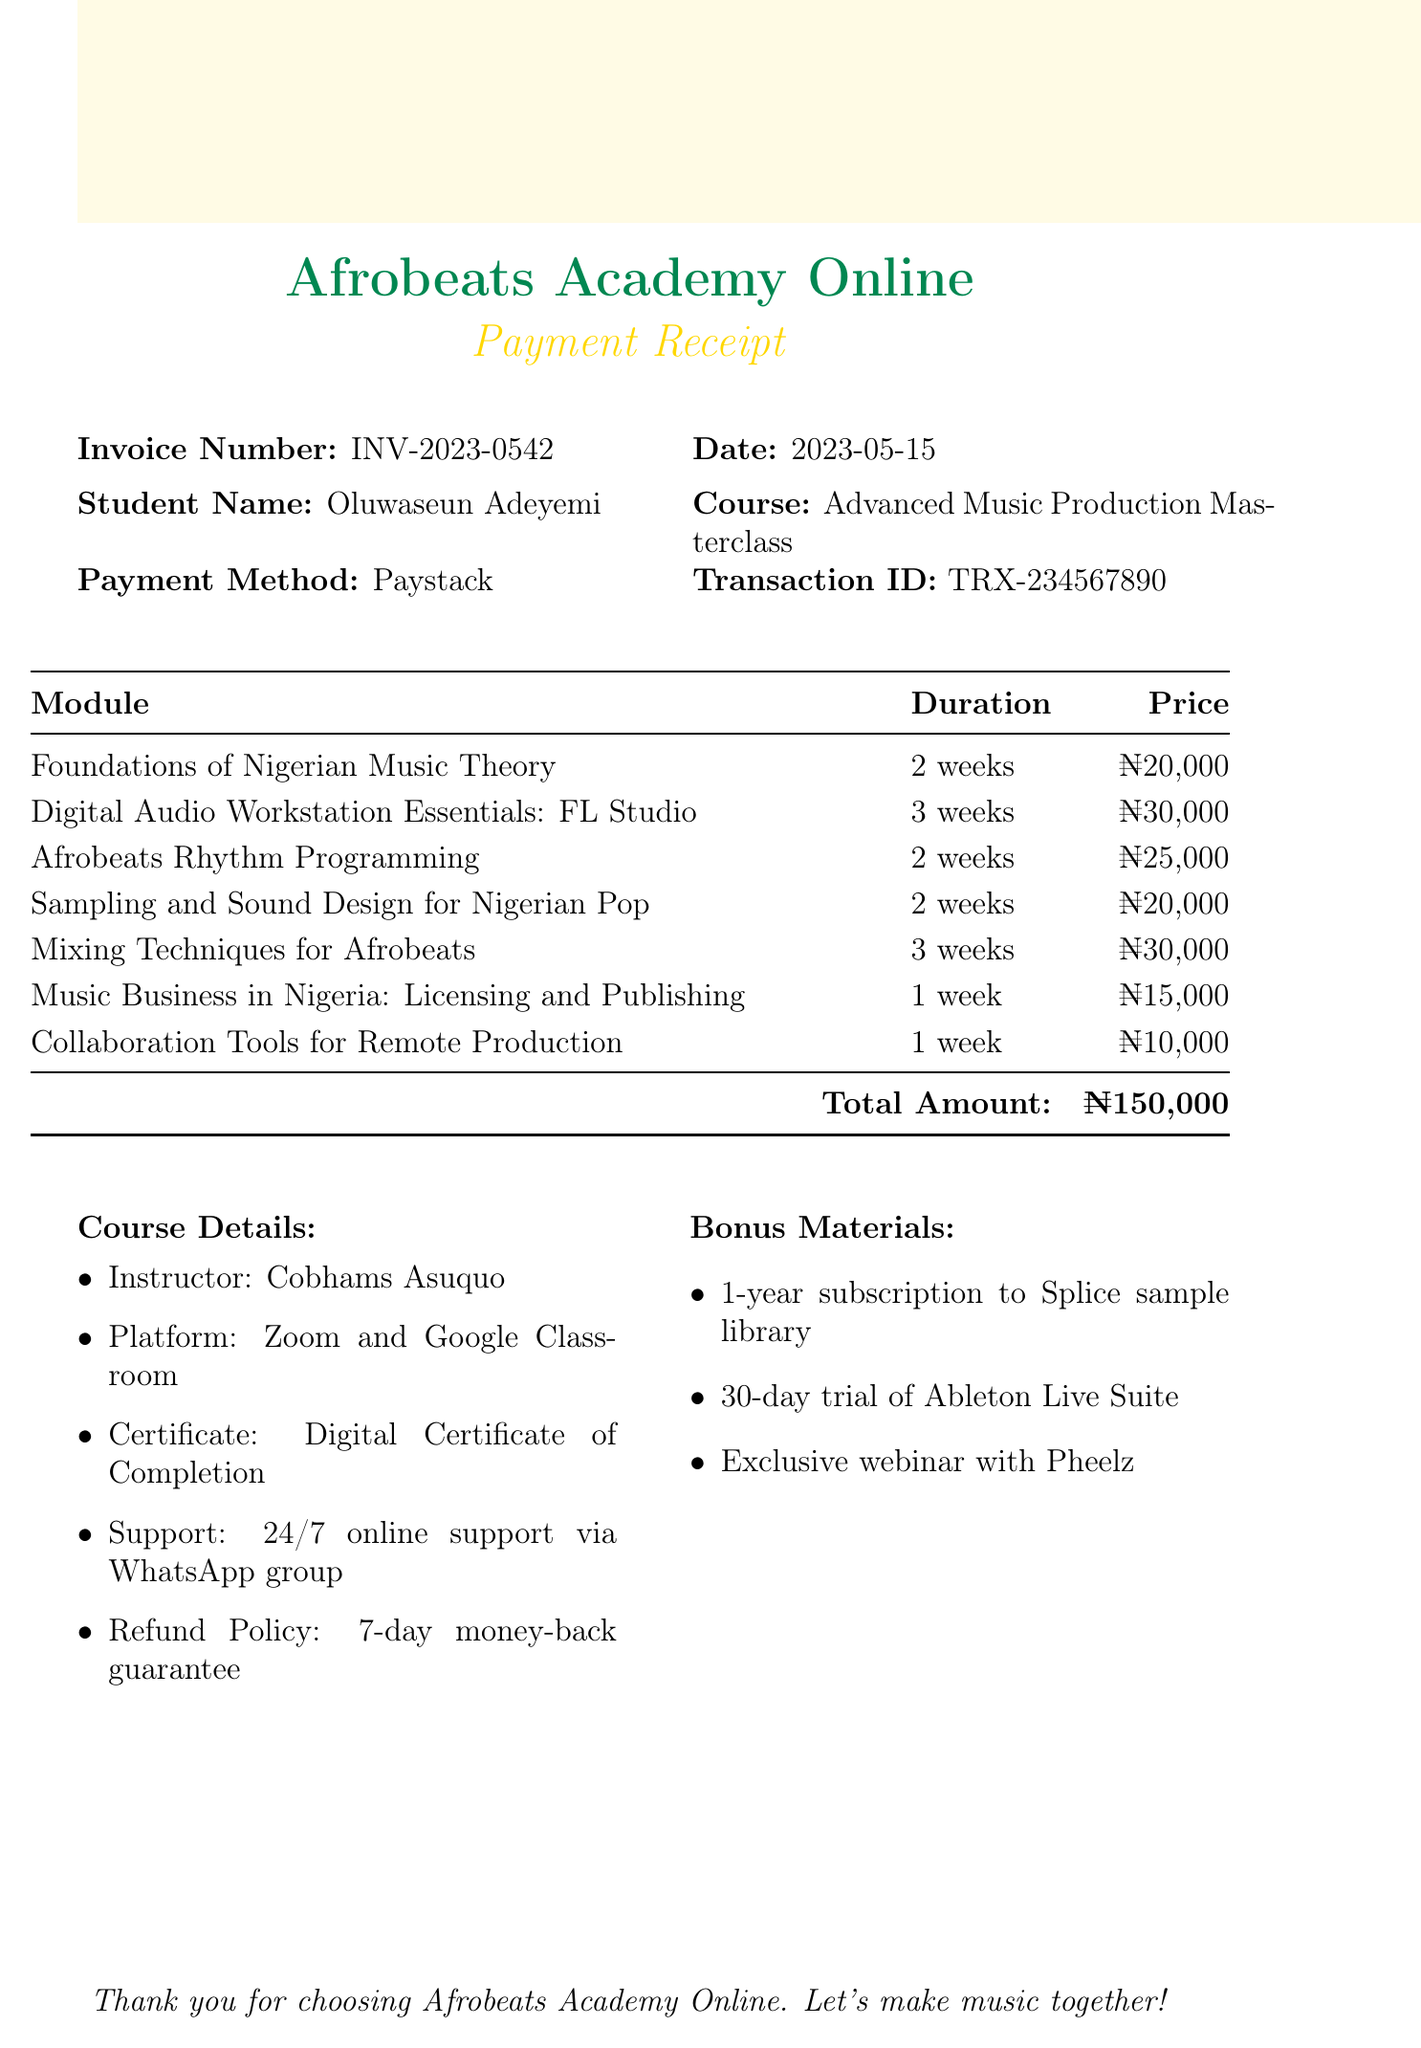What is the invoice number? The invoice number is listed clearly at the top of the document.
Answer: INV-2023-0542 Who is the course instructor? The instructor's name is mentioned in the course details section.
Answer: Cobhams Asuquo What is the total amount paid for the course? The total amount appears in the table where the modules and their prices are listed.
Answer: ₦150,000 How many weeks is the "Digital Audio Workstation Essentials: FL Studio" module? The duration of the module is specified alongside its title in the itemized list.
Answer: 3 weeks What payment method was used? The document states the payment method used by the student.
Answer: Paystack Which bonus material includes a subscription? The bonus materials section lists several offerings, one of which includes a subscription.
Answer: 1-year subscription to Splice sample library Is there a refund policy? The document specifically mentions the refund policy in the course details.
Answer: 7-day money-back guarantee What platform was used for the course? The platform for course delivery is provided in the course details section.
Answer: Zoom and Google Classroom 